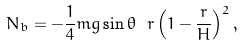Convert formula to latex. <formula><loc_0><loc_0><loc_500><loc_500>N _ { b } = - \frac { 1 } { 4 } m g \sin \theta \ r \left ( 1 - \frac { r } { H } \right ) ^ { 2 } ,</formula> 